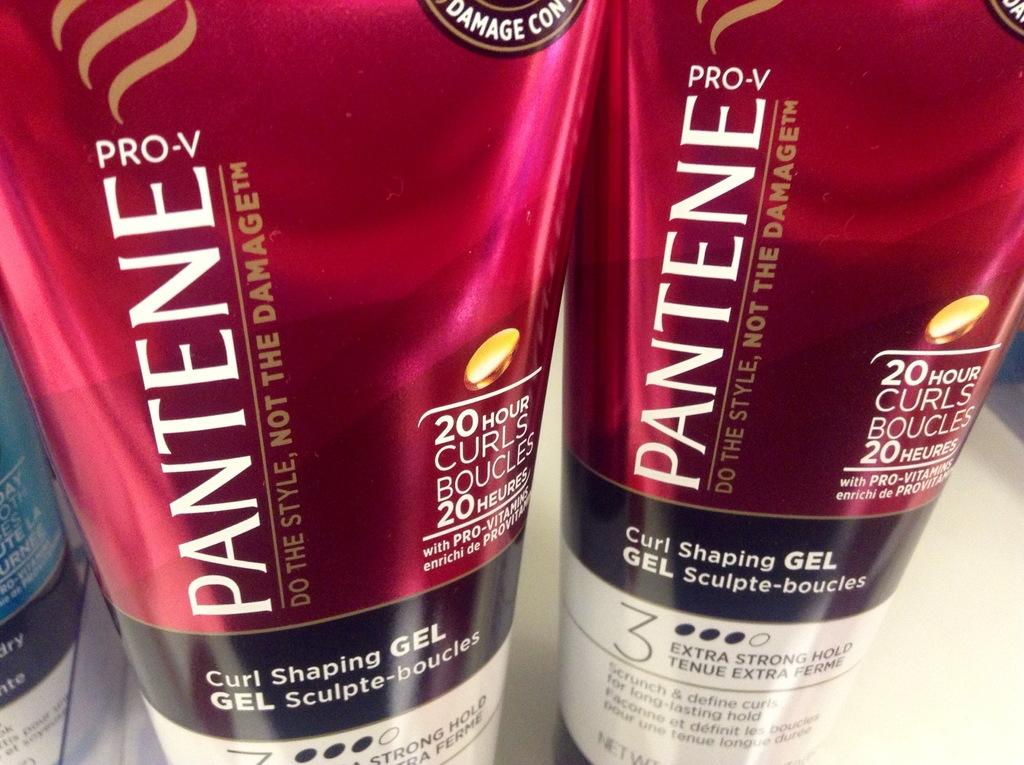<image>
Present a compact description of the photo's key features. Two bottles of Pantene Pro-V hair product sit next to one another. 